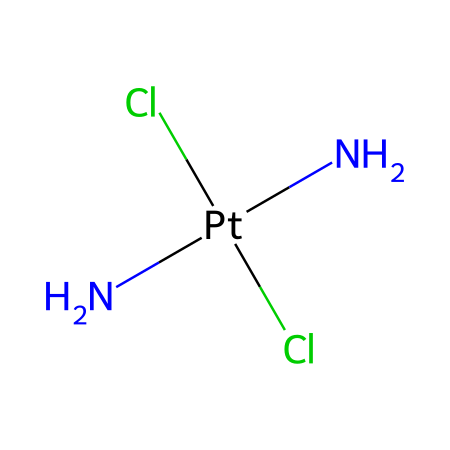What is the coordination number of platinum in this compound? The coordination number refers to the number of atoms or ligands that are directly bonded to the central metal atom. In this case, platinum is bonded to two amine groups (N) and two chloride ions (Cl), totaling four ligands.
Answer: four How many nitrogen atoms are present in the structure? By analyzing the SMILES representation, there are two nitrogen (N) atoms specified in the coordination complex.
Answer: two What type of bonding exists between the platinum and the ligands? The ligands (two nitrogen groups and two chlorine atoms) are attached to platinum primarily through coordinate covalent bonds, which are a specific type of covalent bond formed when both electrons shared in the bond come from one atom, in this case, the N atoms.
Answer: coordinate covalent bonds Which atoms constitute the ligands in this coordination compound? The ligands are the two nitrogen atoms (from the amine groups) and the two chloride ions, which are the atoms directly attached to the platinum center in this compound.
Answer: nitrogen and chloride Is this coordination complex cis or trans? The coordination complex is classified as cis due to the arrangement of the amine (N) groups being adjacent to each other in the structure, while the chloride (Cl) ions are also adjacent, which is characteristic of a cis configuration.
Answer: cis What historical significance does cisplatin have in medicine? Cisplatin was one of the first chemotherapy drugs developed and was introduced in the late 1970s, marking a significant advancement in cancer treatment, particularly for testicular and ovarian cancers. Its discovery has led to the inclusion of platinum-based drugs in cancer treatment regimens.
Answer: significant Which element in this complex is a heavy metal? The central metal atom in the coordination complex is platinum, which is classified as a heavy metal due to its high atomic weight and density.
Answer: platinum 